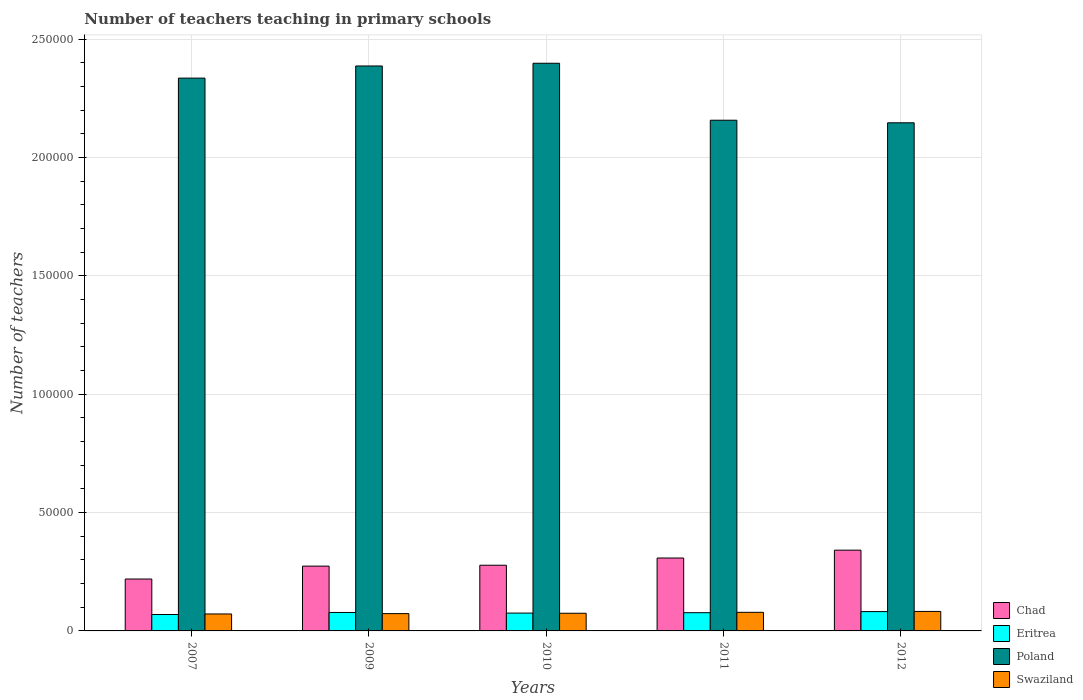How many different coloured bars are there?
Provide a short and direct response. 4. Are the number of bars on each tick of the X-axis equal?
Keep it short and to the point. Yes. How many bars are there on the 4th tick from the left?
Ensure brevity in your answer.  4. What is the number of teachers teaching in primary schools in Chad in 2007?
Offer a very short reply. 2.19e+04. Across all years, what is the maximum number of teachers teaching in primary schools in Chad?
Provide a short and direct response. 3.41e+04. Across all years, what is the minimum number of teachers teaching in primary schools in Chad?
Your answer should be very brief. 2.19e+04. In which year was the number of teachers teaching in primary schools in Swaziland maximum?
Your response must be concise. 2012. In which year was the number of teachers teaching in primary schools in Swaziland minimum?
Keep it short and to the point. 2007. What is the total number of teachers teaching in primary schools in Poland in the graph?
Offer a very short reply. 1.14e+06. What is the difference between the number of teachers teaching in primary schools in Chad in 2007 and that in 2010?
Your response must be concise. -5831. What is the difference between the number of teachers teaching in primary schools in Poland in 2011 and the number of teachers teaching in primary schools in Chad in 2012?
Your response must be concise. 1.82e+05. What is the average number of teachers teaching in primary schools in Swaziland per year?
Your response must be concise. 7608.6. In the year 2011, what is the difference between the number of teachers teaching in primary schools in Swaziland and number of teachers teaching in primary schools in Eritrea?
Provide a short and direct response. 158. In how many years, is the number of teachers teaching in primary schools in Eritrea greater than 240000?
Offer a very short reply. 0. What is the ratio of the number of teachers teaching in primary schools in Eritrea in 2011 to that in 2012?
Offer a very short reply. 0.94. Is the number of teachers teaching in primary schools in Swaziland in 2010 less than that in 2011?
Ensure brevity in your answer.  Yes. What is the difference between the highest and the second highest number of teachers teaching in primary schools in Swaziland?
Offer a terse response. 377. What is the difference between the highest and the lowest number of teachers teaching in primary schools in Swaziland?
Offer a very short reply. 1070. In how many years, is the number of teachers teaching in primary schools in Chad greater than the average number of teachers teaching in primary schools in Chad taken over all years?
Make the answer very short. 2. Is it the case that in every year, the sum of the number of teachers teaching in primary schools in Chad and number of teachers teaching in primary schools in Eritrea is greater than the sum of number of teachers teaching in primary schools in Swaziland and number of teachers teaching in primary schools in Poland?
Your answer should be very brief. Yes. What does the 3rd bar from the left in 2007 represents?
Offer a terse response. Poland. What does the 4th bar from the right in 2010 represents?
Give a very brief answer. Chad. How many bars are there?
Keep it short and to the point. 20. Are all the bars in the graph horizontal?
Provide a short and direct response. No. Are the values on the major ticks of Y-axis written in scientific E-notation?
Provide a succinct answer. No. What is the title of the graph?
Keep it short and to the point. Number of teachers teaching in primary schools. What is the label or title of the X-axis?
Give a very brief answer. Years. What is the label or title of the Y-axis?
Keep it short and to the point. Number of teachers. What is the Number of teachers of Chad in 2007?
Your response must be concise. 2.19e+04. What is the Number of teachers of Eritrea in 2007?
Your answer should be very brief. 6933. What is the Number of teachers of Poland in 2007?
Offer a terse response. 2.34e+05. What is the Number of teachers in Swaziland in 2007?
Provide a short and direct response. 7169. What is the Number of teachers in Chad in 2009?
Your response must be concise. 2.74e+04. What is the Number of teachers of Eritrea in 2009?
Provide a short and direct response. 7802. What is the Number of teachers of Poland in 2009?
Your response must be concise. 2.39e+05. What is the Number of teachers of Swaziland in 2009?
Give a very brief answer. 7310. What is the Number of teachers of Chad in 2010?
Ensure brevity in your answer.  2.78e+04. What is the Number of teachers of Eritrea in 2010?
Offer a very short reply. 7535. What is the Number of teachers in Poland in 2010?
Your answer should be compact. 2.40e+05. What is the Number of teachers in Swaziland in 2010?
Provide a short and direct response. 7463. What is the Number of teachers in Chad in 2011?
Provide a short and direct response. 3.08e+04. What is the Number of teachers in Eritrea in 2011?
Offer a terse response. 7704. What is the Number of teachers in Poland in 2011?
Offer a very short reply. 2.16e+05. What is the Number of teachers of Swaziland in 2011?
Keep it short and to the point. 7862. What is the Number of teachers of Chad in 2012?
Give a very brief answer. 3.41e+04. What is the Number of teachers in Eritrea in 2012?
Make the answer very short. 8166. What is the Number of teachers in Poland in 2012?
Make the answer very short. 2.15e+05. What is the Number of teachers of Swaziland in 2012?
Offer a very short reply. 8239. Across all years, what is the maximum Number of teachers of Chad?
Make the answer very short. 3.41e+04. Across all years, what is the maximum Number of teachers in Eritrea?
Make the answer very short. 8166. Across all years, what is the maximum Number of teachers of Poland?
Your answer should be very brief. 2.40e+05. Across all years, what is the maximum Number of teachers of Swaziland?
Offer a very short reply. 8239. Across all years, what is the minimum Number of teachers in Chad?
Provide a succinct answer. 2.19e+04. Across all years, what is the minimum Number of teachers in Eritrea?
Your response must be concise. 6933. Across all years, what is the minimum Number of teachers in Poland?
Ensure brevity in your answer.  2.15e+05. Across all years, what is the minimum Number of teachers of Swaziland?
Give a very brief answer. 7169. What is the total Number of teachers of Chad in the graph?
Your answer should be compact. 1.42e+05. What is the total Number of teachers of Eritrea in the graph?
Your answer should be compact. 3.81e+04. What is the total Number of teachers of Poland in the graph?
Give a very brief answer. 1.14e+06. What is the total Number of teachers in Swaziland in the graph?
Offer a terse response. 3.80e+04. What is the difference between the Number of teachers of Chad in 2007 and that in 2009?
Provide a succinct answer. -5455. What is the difference between the Number of teachers in Eritrea in 2007 and that in 2009?
Your answer should be compact. -869. What is the difference between the Number of teachers in Poland in 2007 and that in 2009?
Offer a terse response. -5129. What is the difference between the Number of teachers in Swaziland in 2007 and that in 2009?
Ensure brevity in your answer.  -141. What is the difference between the Number of teachers of Chad in 2007 and that in 2010?
Ensure brevity in your answer.  -5831. What is the difference between the Number of teachers of Eritrea in 2007 and that in 2010?
Provide a succinct answer. -602. What is the difference between the Number of teachers of Poland in 2007 and that in 2010?
Provide a succinct answer. -6276. What is the difference between the Number of teachers in Swaziland in 2007 and that in 2010?
Keep it short and to the point. -294. What is the difference between the Number of teachers of Chad in 2007 and that in 2011?
Give a very brief answer. -8880. What is the difference between the Number of teachers of Eritrea in 2007 and that in 2011?
Give a very brief answer. -771. What is the difference between the Number of teachers of Poland in 2007 and that in 2011?
Provide a succinct answer. 1.78e+04. What is the difference between the Number of teachers of Swaziland in 2007 and that in 2011?
Provide a succinct answer. -693. What is the difference between the Number of teachers in Chad in 2007 and that in 2012?
Your response must be concise. -1.22e+04. What is the difference between the Number of teachers in Eritrea in 2007 and that in 2012?
Offer a very short reply. -1233. What is the difference between the Number of teachers of Poland in 2007 and that in 2012?
Give a very brief answer. 1.89e+04. What is the difference between the Number of teachers in Swaziland in 2007 and that in 2012?
Make the answer very short. -1070. What is the difference between the Number of teachers of Chad in 2009 and that in 2010?
Ensure brevity in your answer.  -376. What is the difference between the Number of teachers of Eritrea in 2009 and that in 2010?
Make the answer very short. 267. What is the difference between the Number of teachers of Poland in 2009 and that in 2010?
Ensure brevity in your answer.  -1147. What is the difference between the Number of teachers of Swaziland in 2009 and that in 2010?
Offer a very short reply. -153. What is the difference between the Number of teachers in Chad in 2009 and that in 2011?
Provide a succinct answer. -3425. What is the difference between the Number of teachers in Poland in 2009 and that in 2011?
Your answer should be very brief. 2.29e+04. What is the difference between the Number of teachers in Swaziland in 2009 and that in 2011?
Ensure brevity in your answer.  -552. What is the difference between the Number of teachers of Chad in 2009 and that in 2012?
Keep it short and to the point. -6737. What is the difference between the Number of teachers in Eritrea in 2009 and that in 2012?
Your response must be concise. -364. What is the difference between the Number of teachers in Poland in 2009 and that in 2012?
Provide a short and direct response. 2.40e+04. What is the difference between the Number of teachers of Swaziland in 2009 and that in 2012?
Provide a short and direct response. -929. What is the difference between the Number of teachers of Chad in 2010 and that in 2011?
Give a very brief answer. -3049. What is the difference between the Number of teachers in Eritrea in 2010 and that in 2011?
Provide a short and direct response. -169. What is the difference between the Number of teachers in Poland in 2010 and that in 2011?
Offer a very short reply. 2.41e+04. What is the difference between the Number of teachers in Swaziland in 2010 and that in 2011?
Keep it short and to the point. -399. What is the difference between the Number of teachers in Chad in 2010 and that in 2012?
Offer a very short reply. -6361. What is the difference between the Number of teachers in Eritrea in 2010 and that in 2012?
Keep it short and to the point. -631. What is the difference between the Number of teachers in Poland in 2010 and that in 2012?
Ensure brevity in your answer.  2.52e+04. What is the difference between the Number of teachers in Swaziland in 2010 and that in 2012?
Provide a succinct answer. -776. What is the difference between the Number of teachers in Chad in 2011 and that in 2012?
Your answer should be compact. -3312. What is the difference between the Number of teachers of Eritrea in 2011 and that in 2012?
Your answer should be very brief. -462. What is the difference between the Number of teachers of Poland in 2011 and that in 2012?
Your answer should be very brief. 1083. What is the difference between the Number of teachers of Swaziland in 2011 and that in 2012?
Ensure brevity in your answer.  -377. What is the difference between the Number of teachers in Chad in 2007 and the Number of teachers in Eritrea in 2009?
Your answer should be compact. 1.41e+04. What is the difference between the Number of teachers of Chad in 2007 and the Number of teachers of Poland in 2009?
Make the answer very short. -2.17e+05. What is the difference between the Number of teachers in Chad in 2007 and the Number of teachers in Swaziland in 2009?
Provide a succinct answer. 1.46e+04. What is the difference between the Number of teachers in Eritrea in 2007 and the Number of teachers in Poland in 2009?
Ensure brevity in your answer.  -2.32e+05. What is the difference between the Number of teachers in Eritrea in 2007 and the Number of teachers in Swaziland in 2009?
Offer a terse response. -377. What is the difference between the Number of teachers in Poland in 2007 and the Number of teachers in Swaziland in 2009?
Offer a terse response. 2.26e+05. What is the difference between the Number of teachers in Chad in 2007 and the Number of teachers in Eritrea in 2010?
Your answer should be very brief. 1.44e+04. What is the difference between the Number of teachers in Chad in 2007 and the Number of teachers in Poland in 2010?
Offer a very short reply. -2.18e+05. What is the difference between the Number of teachers in Chad in 2007 and the Number of teachers in Swaziland in 2010?
Keep it short and to the point. 1.45e+04. What is the difference between the Number of teachers in Eritrea in 2007 and the Number of teachers in Poland in 2010?
Provide a short and direct response. -2.33e+05. What is the difference between the Number of teachers of Eritrea in 2007 and the Number of teachers of Swaziland in 2010?
Offer a very short reply. -530. What is the difference between the Number of teachers in Poland in 2007 and the Number of teachers in Swaziland in 2010?
Offer a terse response. 2.26e+05. What is the difference between the Number of teachers in Chad in 2007 and the Number of teachers in Eritrea in 2011?
Provide a short and direct response. 1.42e+04. What is the difference between the Number of teachers of Chad in 2007 and the Number of teachers of Poland in 2011?
Ensure brevity in your answer.  -1.94e+05. What is the difference between the Number of teachers of Chad in 2007 and the Number of teachers of Swaziland in 2011?
Your response must be concise. 1.41e+04. What is the difference between the Number of teachers of Eritrea in 2007 and the Number of teachers of Poland in 2011?
Provide a succinct answer. -2.09e+05. What is the difference between the Number of teachers of Eritrea in 2007 and the Number of teachers of Swaziland in 2011?
Ensure brevity in your answer.  -929. What is the difference between the Number of teachers of Poland in 2007 and the Number of teachers of Swaziland in 2011?
Your answer should be very brief. 2.26e+05. What is the difference between the Number of teachers of Chad in 2007 and the Number of teachers of Eritrea in 2012?
Your response must be concise. 1.38e+04. What is the difference between the Number of teachers of Chad in 2007 and the Number of teachers of Poland in 2012?
Ensure brevity in your answer.  -1.93e+05. What is the difference between the Number of teachers in Chad in 2007 and the Number of teachers in Swaziland in 2012?
Ensure brevity in your answer.  1.37e+04. What is the difference between the Number of teachers in Eritrea in 2007 and the Number of teachers in Poland in 2012?
Your answer should be very brief. -2.08e+05. What is the difference between the Number of teachers of Eritrea in 2007 and the Number of teachers of Swaziland in 2012?
Keep it short and to the point. -1306. What is the difference between the Number of teachers in Poland in 2007 and the Number of teachers in Swaziland in 2012?
Your answer should be very brief. 2.25e+05. What is the difference between the Number of teachers in Chad in 2009 and the Number of teachers in Eritrea in 2010?
Provide a short and direct response. 1.99e+04. What is the difference between the Number of teachers of Chad in 2009 and the Number of teachers of Poland in 2010?
Make the answer very short. -2.12e+05. What is the difference between the Number of teachers of Chad in 2009 and the Number of teachers of Swaziland in 2010?
Make the answer very short. 1.99e+04. What is the difference between the Number of teachers of Eritrea in 2009 and the Number of teachers of Poland in 2010?
Your answer should be very brief. -2.32e+05. What is the difference between the Number of teachers of Eritrea in 2009 and the Number of teachers of Swaziland in 2010?
Offer a very short reply. 339. What is the difference between the Number of teachers in Poland in 2009 and the Number of teachers in Swaziland in 2010?
Keep it short and to the point. 2.31e+05. What is the difference between the Number of teachers of Chad in 2009 and the Number of teachers of Eritrea in 2011?
Make the answer very short. 1.97e+04. What is the difference between the Number of teachers in Chad in 2009 and the Number of teachers in Poland in 2011?
Offer a very short reply. -1.88e+05. What is the difference between the Number of teachers of Chad in 2009 and the Number of teachers of Swaziland in 2011?
Offer a very short reply. 1.95e+04. What is the difference between the Number of teachers in Eritrea in 2009 and the Number of teachers in Poland in 2011?
Offer a terse response. -2.08e+05. What is the difference between the Number of teachers of Eritrea in 2009 and the Number of teachers of Swaziland in 2011?
Your answer should be very brief. -60. What is the difference between the Number of teachers of Poland in 2009 and the Number of teachers of Swaziland in 2011?
Provide a succinct answer. 2.31e+05. What is the difference between the Number of teachers of Chad in 2009 and the Number of teachers of Eritrea in 2012?
Offer a very short reply. 1.92e+04. What is the difference between the Number of teachers in Chad in 2009 and the Number of teachers in Poland in 2012?
Provide a succinct answer. -1.87e+05. What is the difference between the Number of teachers of Chad in 2009 and the Number of teachers of Swaziland in 2012?
Make the answer very short. 1.91e+04. What is the difference between the Number of teachers in Eritrea in 2009 and the Number of teachers in Poland in 2012?
Your answer should be very brief. -2.07e+05. What is the difference between the Number of teachers of Eritrea in 2009 and the Number of teachers of Swaziland in 2012?
Your answer should be very brief. -437. What is the difference between the Number of teachers in Poland in 2009 and the Number of teachers in Swaziland in 2012?
Keep it short and to the point. 2.31e+05. What is the difference between the Number of teachers in Chad in 2010 and the Number of teachers in Eritrea in 2011?
Your response must be concise. 2.01e+04. What is the difference between the Number of teachers in Chad in 2010 and the Number of teachers in Poland in 2011?
Keep it short and to the point. -1.88e+05. What is the difference between the Number of teachers of Chad in 2010 and the Number of teachers of Swaziland in 2011?
Offer a terse response. 1.99e+04. What is the difference between the Number of teachers of Eritrea in 2010 and the Number of teachers of Poland in 2011?
Provide a succinct answer. -2.08e+05. What is the difference between the Number of teachers of Eritrea in 2010 and the Number of teachers of Swaziland in 2011?
Your response must be concise. -327. What is the difference between the Number of teachers in Poland in 2010 and the Number of teachers in Swaziland in 2011?
Keep it short and to the point. 2.32e+05. What is the difference between the Number of teachers of Chad in 2010 and the Number of teachers of Eritrea in 2012?
Your response must be concise. 1.96e+04. What is the difference between the Number of teachers of Chad in 2010 and the Number of teachers of Poland in 2012?
Make the answer very short. -1.87e+05. What is the difference between the Number of teachers of Chad in 2010 and the Number of teachers of Swaziland in 2012?
Ensure brevity in your answer.  1.95e+04. What is the difference between the Number of teachers in Eritrea in 2010 and the Number of teachers in Poland in 2012?
Give a very brief answer. -2.07e+05. What is the difference between the Number of teachers in Eritrea in 2010 and the Number of teachers in Swaziland in 2012?
Offer a very short reply. -704. What is the difference between the Number of teachers in Poland in 2010 and the Number of teachers in Swaziland in 2012?
Provide a short and direct response. 2.32e+05. What is the difference between the Number of teachers of Chad in 2011 and the Number of teachers of Eritrea in 2012?
Ensure brevity in your answer.  2.26e+04. What is the difference between the Number of teachers in Chad in 2011 and the Number of teachers in Poland in 2012?
Provide a succinct answer. -1.84e+05. What is the difference between the Number of teachers in Chad in 2011 and the Number of teachers in Swaziland in 2012?
Keep it short and to the point. 2.26e+04. What is the difference between the Number of teachers in Eritrea in 2011 and the Number of teachers in Poland in 2012?
Offer a very short reply. -2.07e+05. What is the difference between the Number of teachers of Eritrea in 2011 and the Number of teachers of Swaziland in 2012?
Your response must be concise. -535. What is the difference between the Number of teachers of Poland in 2011 and the Number of teachers of Swaziland in 2012?
Offer a very short reply. 2.08e+05. What is the average Number of teachers in Chad per year?
Keep it short and to the point. 2.84e+04. What is the average Number of teachers of Eritrea per year?
Give a very brief answer. 7628. What is the average Number of teachers in Poland per year?
Provide a short and direct response. 2.29e+05. What is the average Number of teachers of Swaziland per year?
Your answer should be compact. 7608.6. In the year 2007, what is the difference between the Number of teachers in Chad and Number of teachers in Eritrea?
Make the answer very short. 1.50e+04. In the year 2007, what is the difference between the Number of teachers in Chad and Number of teachers in Poland?
Your answer should be very brief. -2.12e+05. In the year 2007, what is the difference between the Number of teachers in Chad and Number of teachers in Swaziland?
Ensure brevity in your answer.  1.48e+04. In the year 2007, what is the difference between the Number of teachers of Eritrea and Number of teachers of Poland?
Offer a very short reply. -2.27e+05. In the year 2007, what is the difference between the Number of teachers of Eritrea and Number of teachers of Swaziland?
Provide a short and direct response. -236. In the year 2007, what is the difference between the Number of teachers of Poland and Number of teachers of Swaziland?
Provide a short and direct response. 2.26e+05. In the year 2009, what is the difference between the Number of teachers in Chad and Number of teachers in Eritrea?
Offer a very short reply. 1.96e+04. In the year 2009, what is the difference between the Number of teachers of Chad and Number of teachers of Poland?
Offer a very short reply. -2.11e+05. In the year 2009, what is the difference between the Number of teachers in Chad and Number of teachers in Swaziland?
Provide a succinct answer. 2.01e+04. In the year 2009, what is the difference between the Number of teachers in Eritrea and Number of teachers in Poland?
Your answer should be compact. -2.31e+05. In the year 2009, what is the difference between the Number of teachers in Eritrea and Number of teachers in Swaziland?
Ensure brevity in your answer.  492. In the year 2009, what is the difference between the Number of teachers in Poland and Number of teachers in Swaziland?
Ensure brevity in your answer.  2.31e+05. In the year 2010, what is the difference between the Number of teachers in Chad and Number of teachers in Eritrea?
Provide a succinct answer. 2.02e+04. In the year 2010, what is the difference between the Number of teachers in Chad and Number of teachers in Poland?
Provide a short and direct response. -2.12e+05. In the year 2010, what is the difference between the Number of teachers of Chad and Number of teachers of Swaziland?
Ensure brevity in your answer.  2.03e+04. In the year 2010, what is the difference between the Number of teachers of Eritrea and Number of teachers of Poland?
Give a very brief answer. -2.32e+05. In the year 2010, what is the difference between the Number of teachers of Poland and Number of teachers of Swaziland?
Give a very brief answer. 2.32e+05. In the year 2011, what is the difference between the Number of teachers in Chad and Number of teachers in Eritrea?
Ensure brevity in your answer.  2.31e+04. In the year 2011, what is the difference between the Number of teachers of Chad and Number of teachers of Poland?
Offer a terse response. -1.85e+05. In the year 2011, what is the difference between the Number of teachers in Chad and Number of teachers in Swaziland?
Ensure brevity in your answer.  2.30e+04. In the year 2011, what is the difference between the Number of teachers of Eritrea and Number of teachers of Poland?
Provide a succinct answer. -2.08e+05. In the year 2011, what is the difference between the Number of teachers of Eritrea and Number of teachers of Swaziland?
Keep it short and to the point. -158. In the year 2011, what is the difference between the Number of teachers of Poland and Number of teachers of Swaziland?
Provide a succinct answer. 2.08e+05. In the year 2012, what is the difference between the Number of teachers of Chad and Number of teachers of Eritrea?
Your answer should be very brief. 2.60e+04. In the year 2012, what is the difference between the Number of teachers in Chad and Number of teachers in Poland?
Provide a short and direct response. -1.81e+05. In the year 2012, what is the difference between the Number of teachers in Chad and Number of teachers in Swaziland?
Offer a very short reply. 2.59e+04. In the year 2012, what is the difference between the Number of teachers in Eritrea and Number of teachers in Poland?
Keep it short and to the point. -2.07e+05. In the year 2012, what is the difference between the Number of teachers in Eritrea and Number of teachers in Swaziland?
Provide a succinct answer. -73. In the year 2012, what is the difference between the Number of teachers of Poland and Number of teachers of Swaziland?
Give a very brief answer. 2.06e+05. What is the ratio of the Number of teachers of Chad in 2007 to that in 2009?
Give a very brief answer. 0.8. What is the ratio of the Number of teachers in Eritrea in 2007 to that in 2009?
Give a very brief answer. 0.89. What is the ratio of the Number of teachers of Poland in 2007 to that in 2009?
Offer a terse response. 0.98. What is the ratio of the Number of teachers of Swaziland in 2007 to that in 2009?
Offer a terse response. 0.98. What is the ratio of the Number of teachers in Chad in 2007 to that in 2010?
Make the answer very short. 0.79. What is the ratio of the Number of teachers in Eritrea in 2007 to that in 2010?
Your response must be concise. 0.92. What is the ratio of the Number of teachers of Poland in 2007 to that in 2010?
Make the answer very short. 0.97. What is the ratio of the Number of teachers of Swaziland in 2007 to that in 2010?
Give a very brief answer. 0.96. What is the ratio of the Number of teachers in Chad in 2007 to that in 2011?
Give a very brief answer. 0.71. What is the ratio of the Number of teachers in Eritrea in 2007 to that in 2011?
Offer a terse response. 0.9. What is the ratio of the Number of teachers of Poland in 2007 to that in 2011?
Ensure brevity in your answer.  1.08. What is the ratio of the Number of teachers in Swaziland in 2007 to that in 2011?
Your answer should be very brief. 0.91. What is the ratio of the Number of teachers of Chad in 2007 to that in 2012?
Your answer should be very brief. 0.64. What is the ratio of the Number of teachers in Eritrea in 2007 to that in 2012?
Offer a very short reply. 0.85. What is the ratio of the Number of teachers of Poland in 2007 to that in 2012?
Offer a very short reply. 1.09. What is the ratio of the Number of teachers of Swaziland in 2007 to that in 2012?
Give a very brief answer. 0.87. What is the ratio of the Number of teachers in Chad in 2009 to that in 2010?
Provide a succinct answer. 0.99. What is the ratio of the Number of teachers in Eritrea in 2009 to that in 2010?
Ensure brevity in your answer.  1.04. What is the ratio of the Number of teachers in Poland in 2009 to that in 2010?
Your response must be concise. 1. What is the ratio of the Number of teachers of Swaziland in 2009 to that in 2010?
Ensure brevity in your answer.  0.98. What is the ratio of the Number of teachers of Chad in 2009 to that in 2011?
Your answer should be compact. 0.89. What is the ratio of the Number of teachers of Eritrea in 2009 to that in 2011?
Make the answer very short. 1.01. What is the ratio of the Number of teachers of Poland in 2009 to that in 2011?
Keep it short and to the point. 1.11. What is the ratio of the Number of teachers in Swaziland in 2009 to that in 2011?
Provide a short and direct response. 0.93. What is the ratio of the Number of teachers in Chad in 2009 to that in 2012?
Provide a succinct answer. 0.8. What is the ratio of the Number of teachers in Eritrea in 2009 to that in 2012?
Make the answer very short. 0.96. What is the ratio of the Number of teachers of Poland in 2009 to that in 2012?
Ensure brevity in your answer.  1.11. What is the ratio of the Number of teachers in Swaziland in 2009 to that in 2012?
Make the answer very short. 0.89. What is the ratio of the Number of teachers of Chad in 2010 to that in 2011?
Offer a very short reply. 0.9. What is the ratio of the Number of teachers of Eritrea in 2010 to that in 2011?
Provide a short and direct response. 0.98. What is the ratio of the Number of teachers in Poland in 2010 to that in 2011?
Offer a very short reply. 1.11. What is the ratio of the Number of teachers in Swaziland in 2010 to that in 2011?
Your response must be concise. 0.95. What is the ratio of the Number of teachers of Chad in 2010 to that in 2012?
Your answer should be very brief. 0.81. What is the ratio of the Number of teachers of Eritrea in 2010 to that in 2012?
Your answer should be very brief. 0.92. What is the ratio of the Number of teachers in Poland in 2010 to that in 2012?
Offer a very short reply. 1.12. What is the ratio of the Number of teachers of Swaziland in 2010 to that in 2012?
Provide a short and direct response. 0.91. What is the ratio of the Number of teachers of Chad in 2011 to that in 2012?
Give a very brief answer. 0.9. What is the ratio of the Number of teachers of Eritrea in 2011 to that in 2012?
Your answer should be compact. 0.94. What is the ratio of the Number of teachers of Poland in 2011 to that in 2012?
Offer a very short reply. 1. What is the ratio of the Number of teachers in Swaziland in 2011 to that in 2012?
Provide a short and direct response. 0.95. What is the difference between the highest and the second highest Number of teachers in Chad?
Ensure brevity in your answer.  3312. What is the difference between the highest and the second highest Number of teachers of Eritrea?
Offer a terse response. 364. What is the difference between the highest and the second highest Number of teachers of Poland?
Offer a very short reply. 1147. What is the difference between the highest and the second highest Number of teachers in Swaziland?
Give a very brief answer. 377. What is the difference between the highest and the lowest Number of teachers of Chad?
Provide a succinct answer. 1.22e+04. What is the difference between the highest and the lowest Number of teachers of Eritrea?
Your answer should be very brief. 1233. What is the difference between the highest and the lowest Number of teachers in Poland?
Offer a terse response. 2.52e+04. What is the difference between the highest and the lowest Number of teachers in Swaziland?
Offer a very short reply. 1070. 